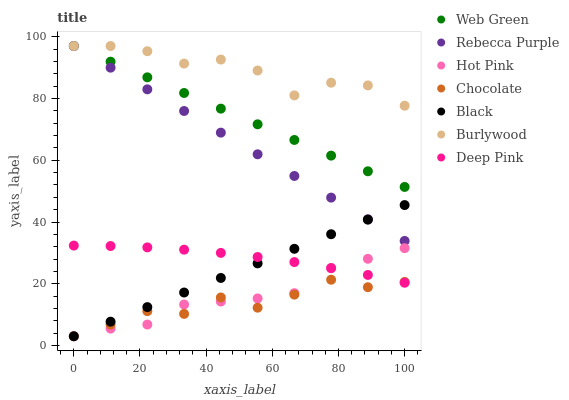Does Chocolate have the minimum area under the curve?
Answer yes or no. Yes. Does Burlywood have the maximum area under the curve?
Answer yes or no. Yes. Does Hot Pink have the minimum area under the curve?
Answer yes or no. No. Does Hot Pink have the maximum area under the curve?
Answer yes or no. No. Is Black the smoothest?
Answer yes or no. Yes. Is Burlywood the roughest?
Answer yes or no. Yes. Is Hot Pink the smoothest?
Answer yes or no. No. Is Hot Pink the roughest?
Answer yes or no. No. Does Hot Pink have the lowest value?
Answer yes or no. Yes. Does Burlywood have the lowest value?
Answer yes or no. No. Does Rebecca Purple have the highest value?
Answer yes or no. Yes. Does Hot Pink have the highest value?
Answer yes or no. No. Is Deep Pink less than Web Green?
Answer yes or no. Yes. Is Web Green greater than Black?
Answer yes or no. Yes. Does Rebecca Purple intersect Web Green?
Answer yes or no. Yes. Is Rebecca Purple less than Web Green?
Answer yes or no. No. Is Rebecca Purple greater than Web Green?
Answer yes or no. No. Does Deep Pink intersect Web Green?
Answer yes or no. No. 